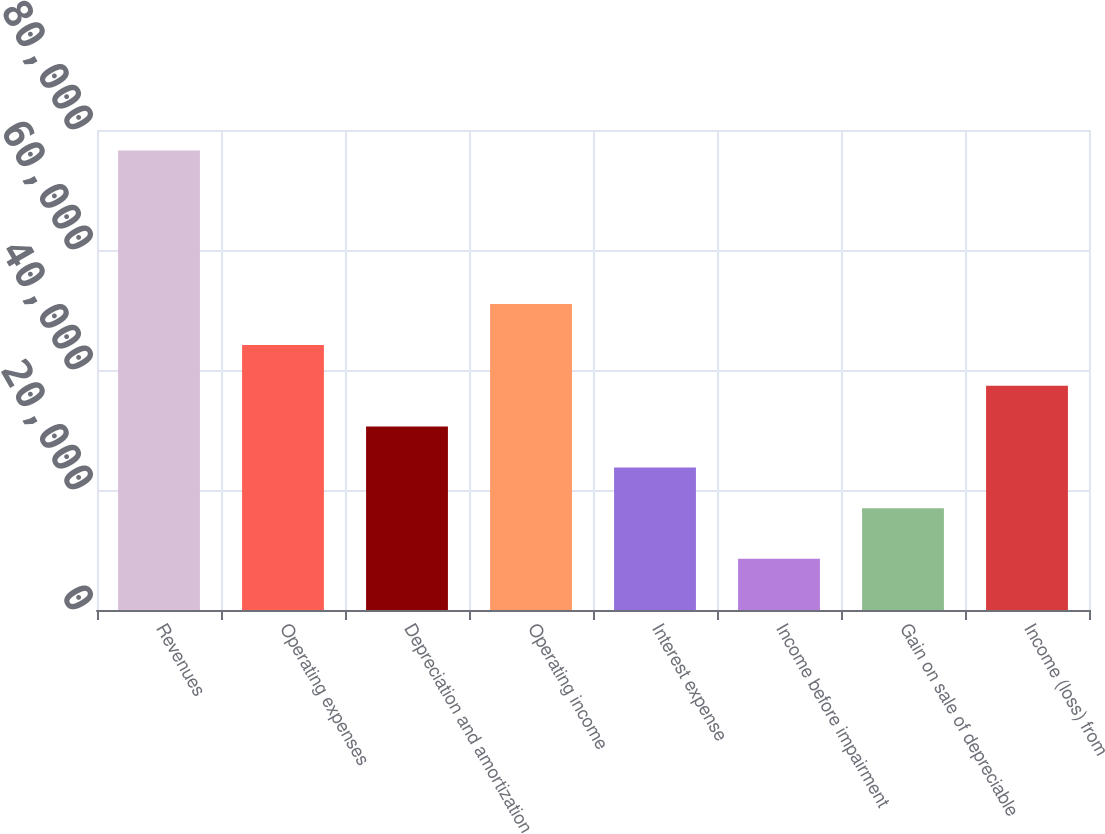Convert chart to OTSL. <chart><loc_0><loc_0><loc_500><loc_500><bar_chart><fcel>Revenues<fcel>Operating expenses<fcel>Depreciation and amortization<fcel>Operating income<fcel>Interest expense<fcel>Income before impairment<fcel>Gain on sale of depreciable<fcel>Income (loss) from<nl><fcel>76593<fcel>44179.8<fcel>30570.4<fcel>50984.5<fcel>23765.7<fcel>8546<fcel>16961<fcel>37375.1<nl></chart> 